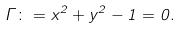Convert formula to latex. <formula><loc_0><loc_0><loc_500><loc_500>\Gamma \colon = x ^ { 2 } + y ^ { 2 } - 1 = 0 .</formula> 